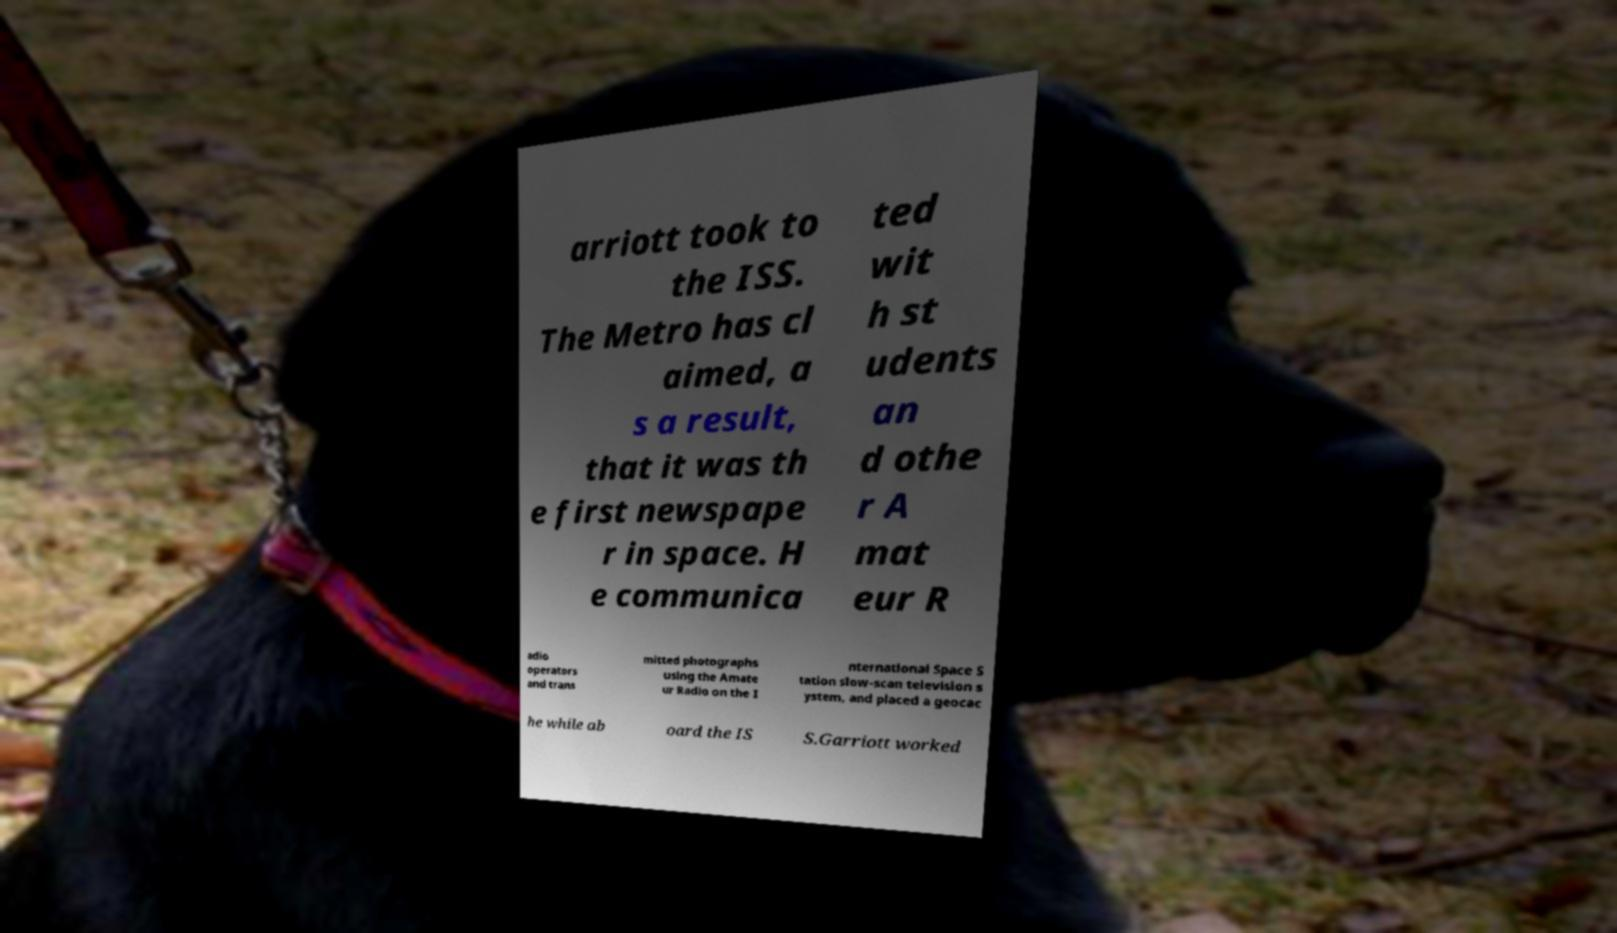Can you read and provide the text displayed in the image?This photo seems to have some interesting text. Can you extract and type it out for me? arriott took to the ISS. The Metro has cl aimed, a s a result, that it was th e first newspape r in space. H e communica ted wit h st udents an d othe r A mat eur R adio operators and trans mitted photographs using the Amate ur Radio on the I nternational Space S tation slow-scan television s ystem, and placed a geocac he while ab oard the IS S.Garriott worked 